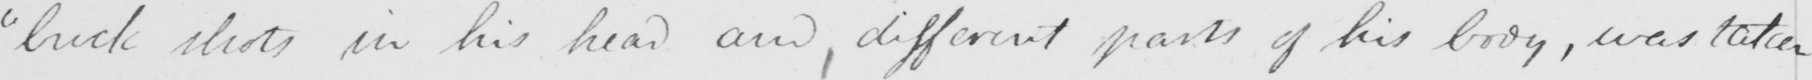Please transcribe the handwritten text in this image. " buck shots in his head and different parts of his body , was taken 